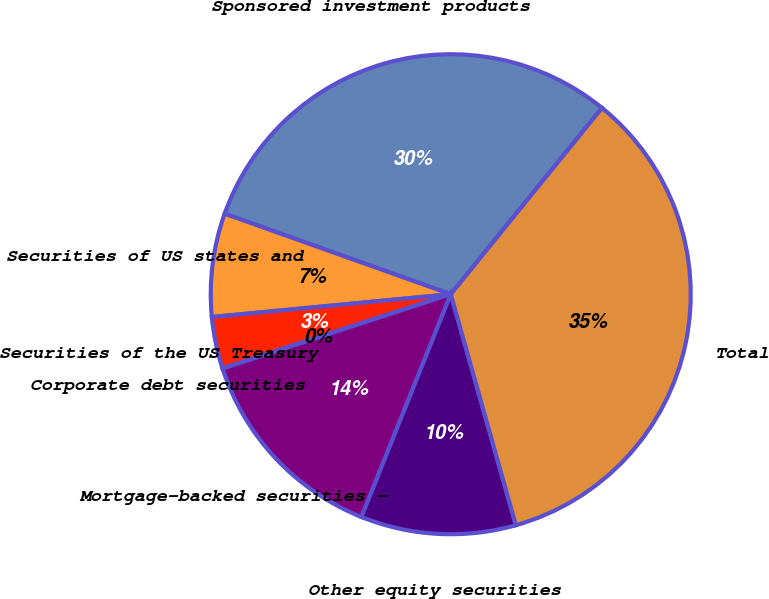Convert chart to OTSL. <chart><loc_0><loc_0><loc_500><loc_500><pie_chart><fcel>Sponsored investment products<fcel>Securities of US states and<fcel>Securities of the US Treasury<fcel>Corporate debt securities<fcel>Mortgage-backed securities -<fcel>Other equity securities<fcel>Total<nl><fcel>30.41%<fcel>6.96%<fcel>3.49%<fcel>0.01%<fcel>13.92%<fcel>10.44%<fcel>34.78%<nl></chart> 